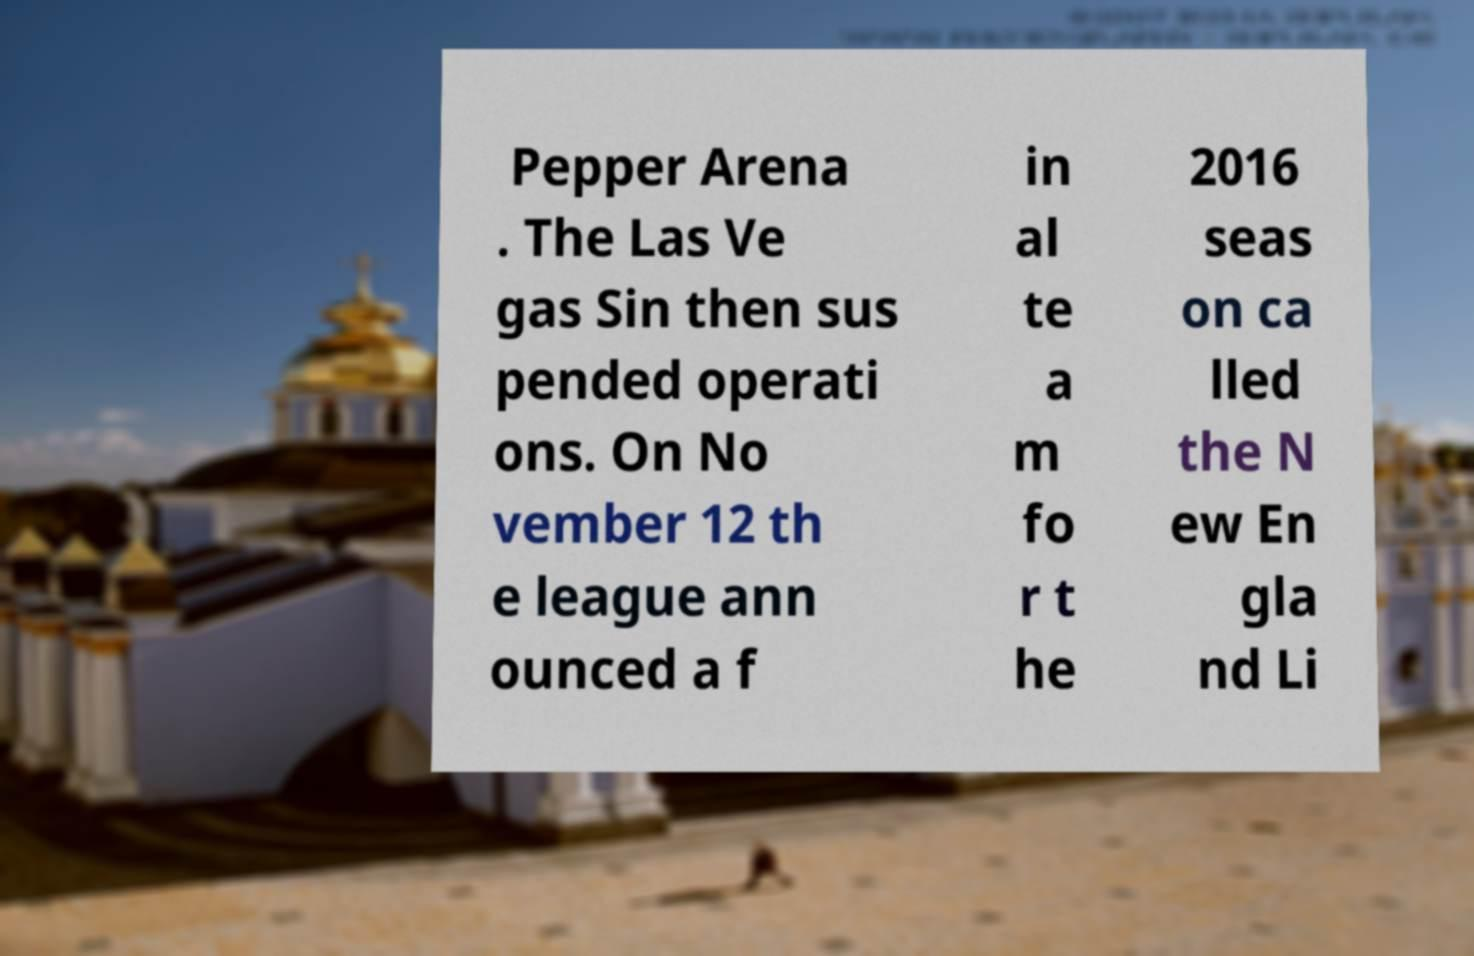Can you accurately transcribe the text from the provided image for me? Pepper Arena . The Las Ve gas Sin then sus pended operati ons. On No vember 12 th e league ann ounced a f in al te a m fo r t he 2016 seas on ca lled the N ew En gla nd Li 